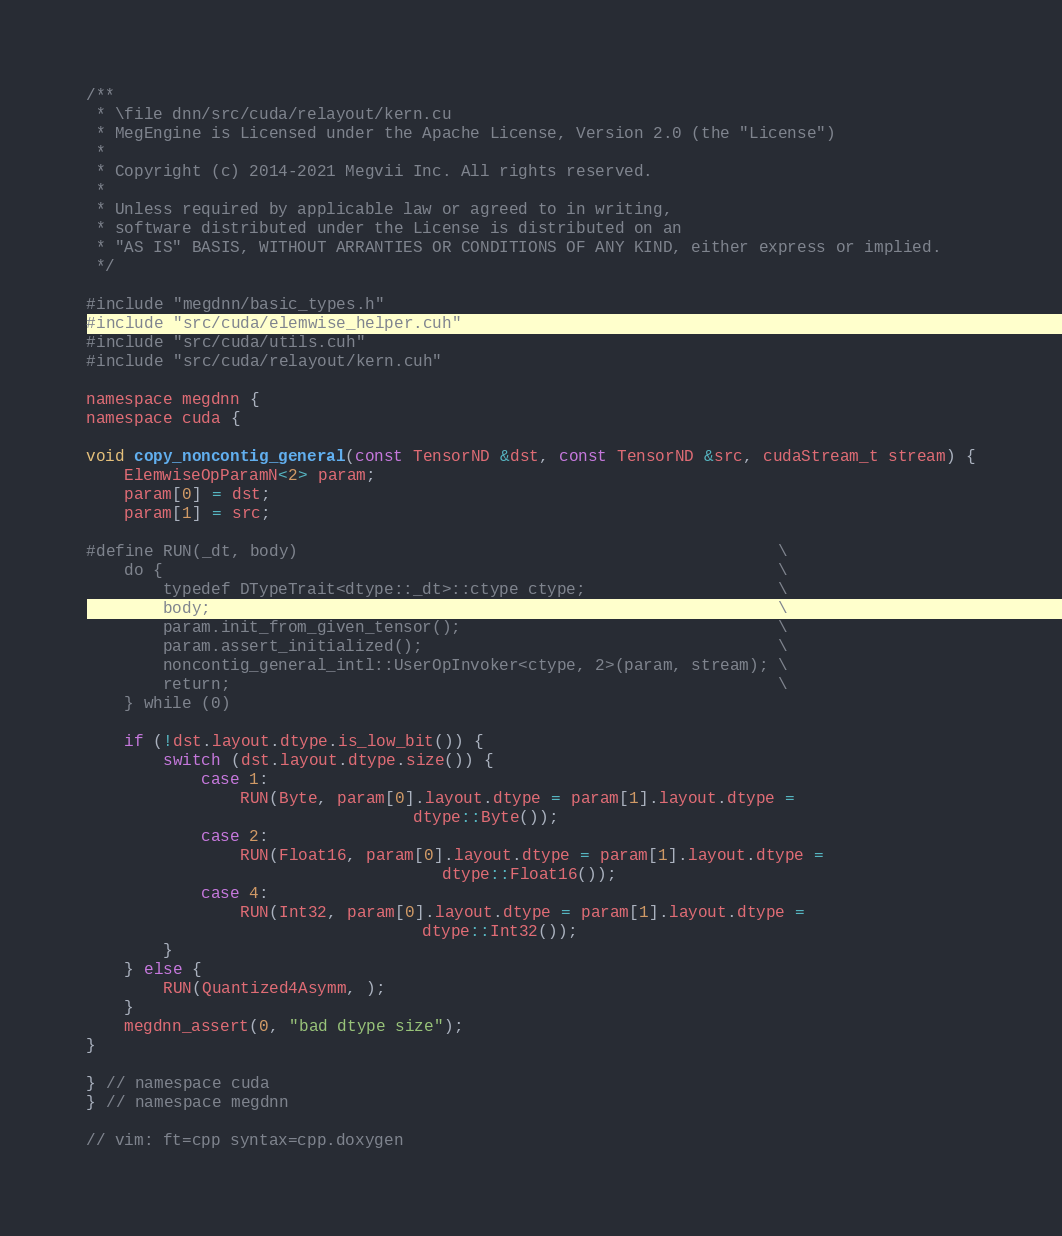<code> <loc_0><loc_0><loc_500><loc_500><_Cuda_>/**
 * \file dnn/src/cuda/relayout/kern.cu
 * MegEngine is Licensed under the Apache License, Version 2.0 (the "License")
 *
 * Copyright (c) 2014-2021 Megvii Inc. All rights reserved.
 *
 * Unless required by applicable law or agreed to in writing,
 * software distributed under the License is distributed on an
 * "AS IS" BASIS, WITHOUT ARRANTIES OR CONDITIONS OF ANY KIND, either express or implied.
 */

#include "megdnn/basic_types.h"
#include "src/cuda/elemwise_helper.cuh"
#include "src/cuda/utils.cuh"
#include "src/cuda/relayout/kern.cuh"

namespace megdnn {
namespace cuda {

void copy_noncontig_general(const TensorND &dst, const TensorND &src, cudaStream_t stream) {
    ElemwiseOpParamN<2> param;
    param[0] = dst;
    param[1] = src;

#define RUN(_dt, body)                                                  \
    do {                                                                \
        typedef DTypeTrait<dtype::_dt>::ctype ctype;                    \
        body;                                                           \
        param.init_from_given_tensor();                                 \
        param.assert_initialized();                                     \
        noncontig_general_intl::UserOpInvoker<ctype, 2>(param, stream); \
        return;                                                         \
    } while (0)

    if (!dst.layout.dtype.is_low_bit()) {
        switch (dst.layout.dtype.size()) {
            case 1:
                RUN(Byte, param[0].layout.dtype = param[1].layout.dtype =
                                  dtype::Byte());
            case 2:
                RUN(Float16, param[0].layout.dtype = param[1].layout.dtype =
                                     dtype::Float16());
            case 4:
                RUN(Int32, param[0].layout.dtype = param[1].layout.dtype =
                                   dtype::Int32());
        }
    } else {
        RUN(Quantized4Asymm, );
    }
    megdnn_assert(0, "bad dtype size");
}

} // namespace cuda
} // namespace megdnn

// vim: ft=cpp syntax=cpp.doxygen
</code> 